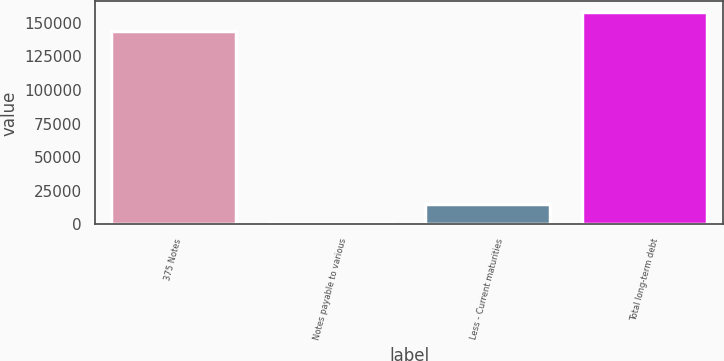Convert chart. <chart><loc_0><loc_0><loc_500><loc_500><bar_chart><fcel>375 Notes<fcel>Notes payable to various<fcel>Less - Current maturities<fcel>Total long-term debt<nl><fcel>143750<fcel>1155<fcel>15414.5<fcel>158010<nl></chart> 